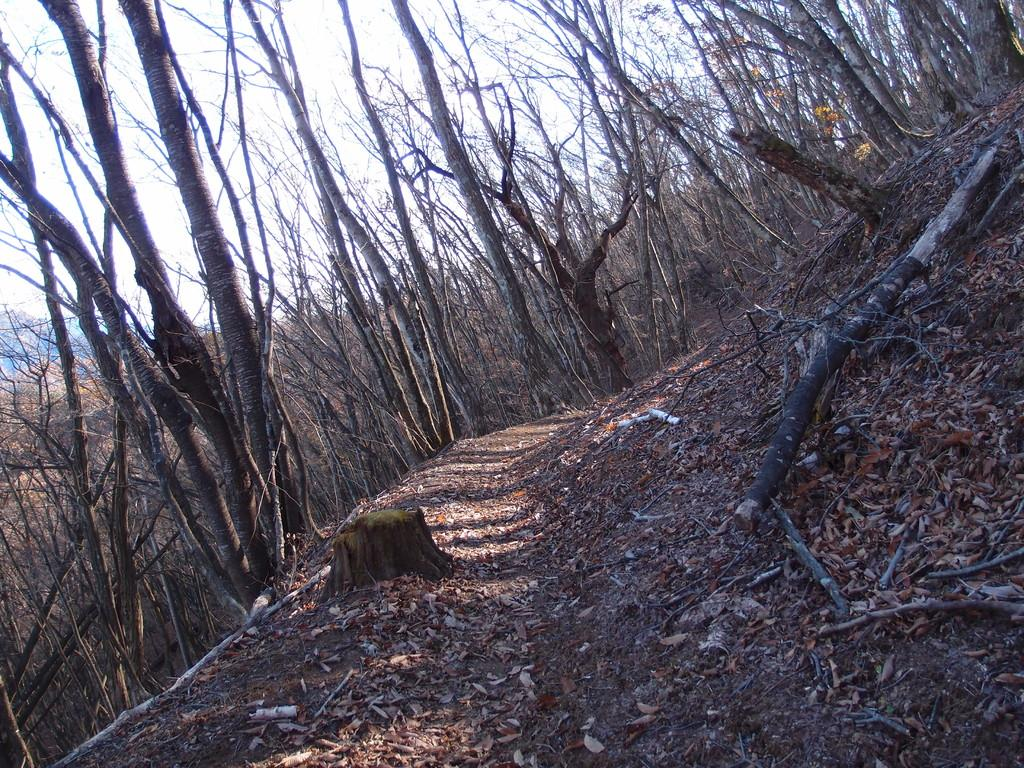What type of natural material can be seen on the ground in the image? There are dried leaves and wooden logs on the ground in the image. What type of vegetation is present in the image? There are trees in the image. What can be seen in the background of the image? The sky is visible in the background of the image. Can you tell me how many skateboards are hidden in the wilderness in the image? There are no skateboards or references to wilderness present in the image; it features dried leaves, wooden logs, trees, and the sky. 